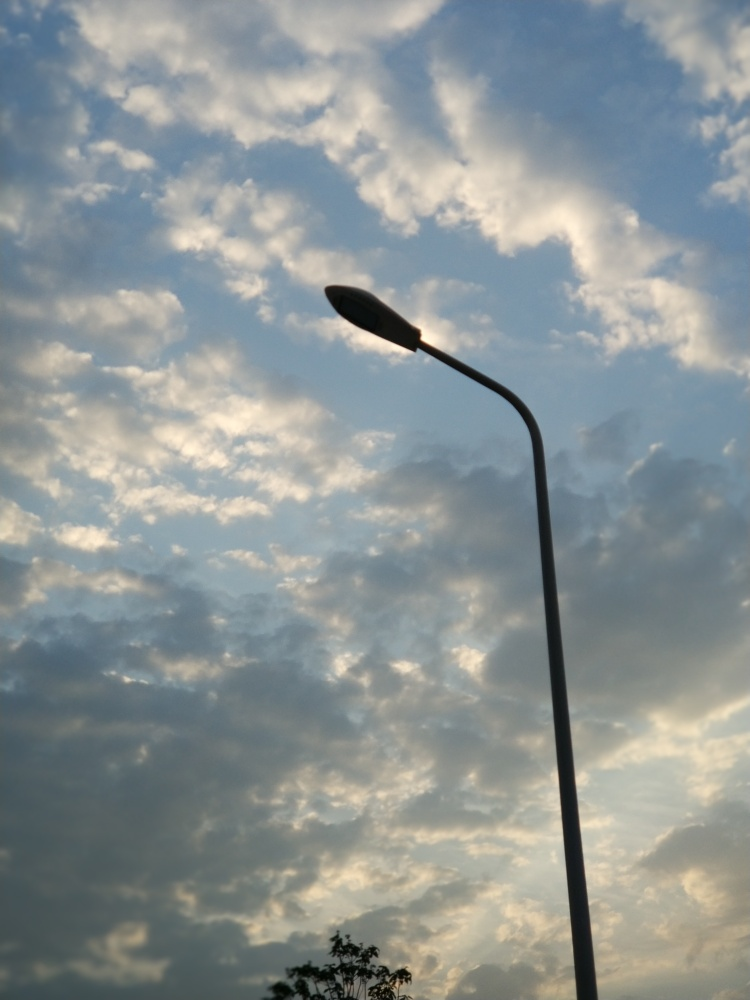Can we predict the weather from this image? What does the cloud formation tell us? The clouds depicted are cumulus, which are often associated with fair weather when they appear scattered in a blue sky. However, if they begin to group together, it can indicate that a change in the weather may be on the horizon, potentially bringing showers or storms. 